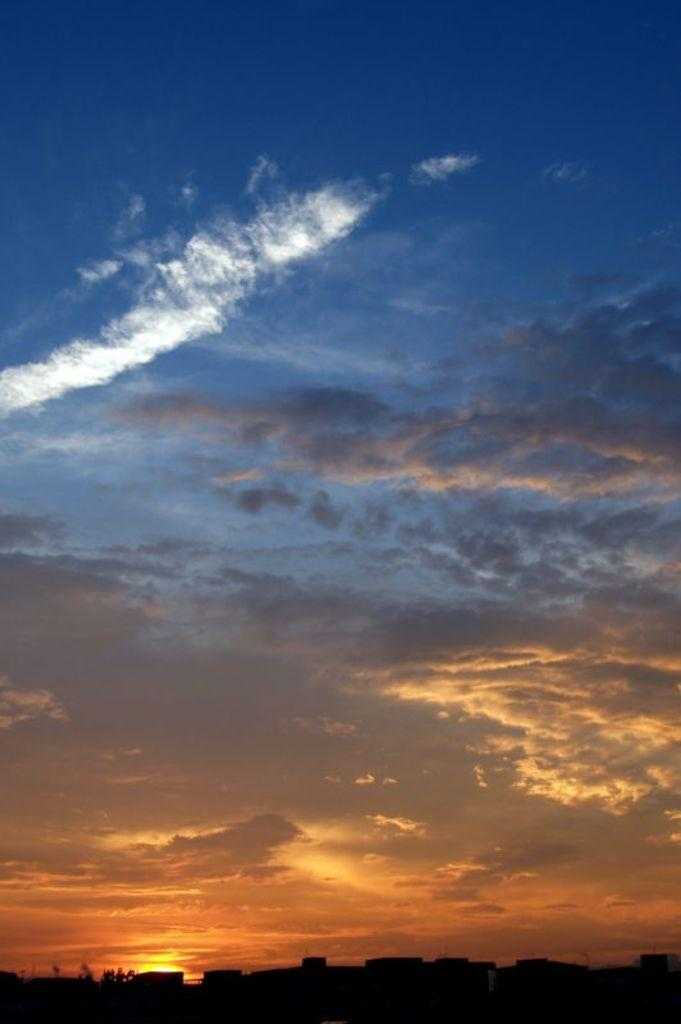What part of the natural environment can be seen in the image? The sky is visible in the image. What can be observed in the sky? Clouds are present in the sky. What is the color or lighting condition at the bottom of the image? The bottom of the image is dark. What type of vegetation is visible in the image? Trees are visible in the image. Where is the airport located in the image? There is no airport present in the image. What type of paper is being used to write on in the image? There is no paper or writing activity present in the image. 